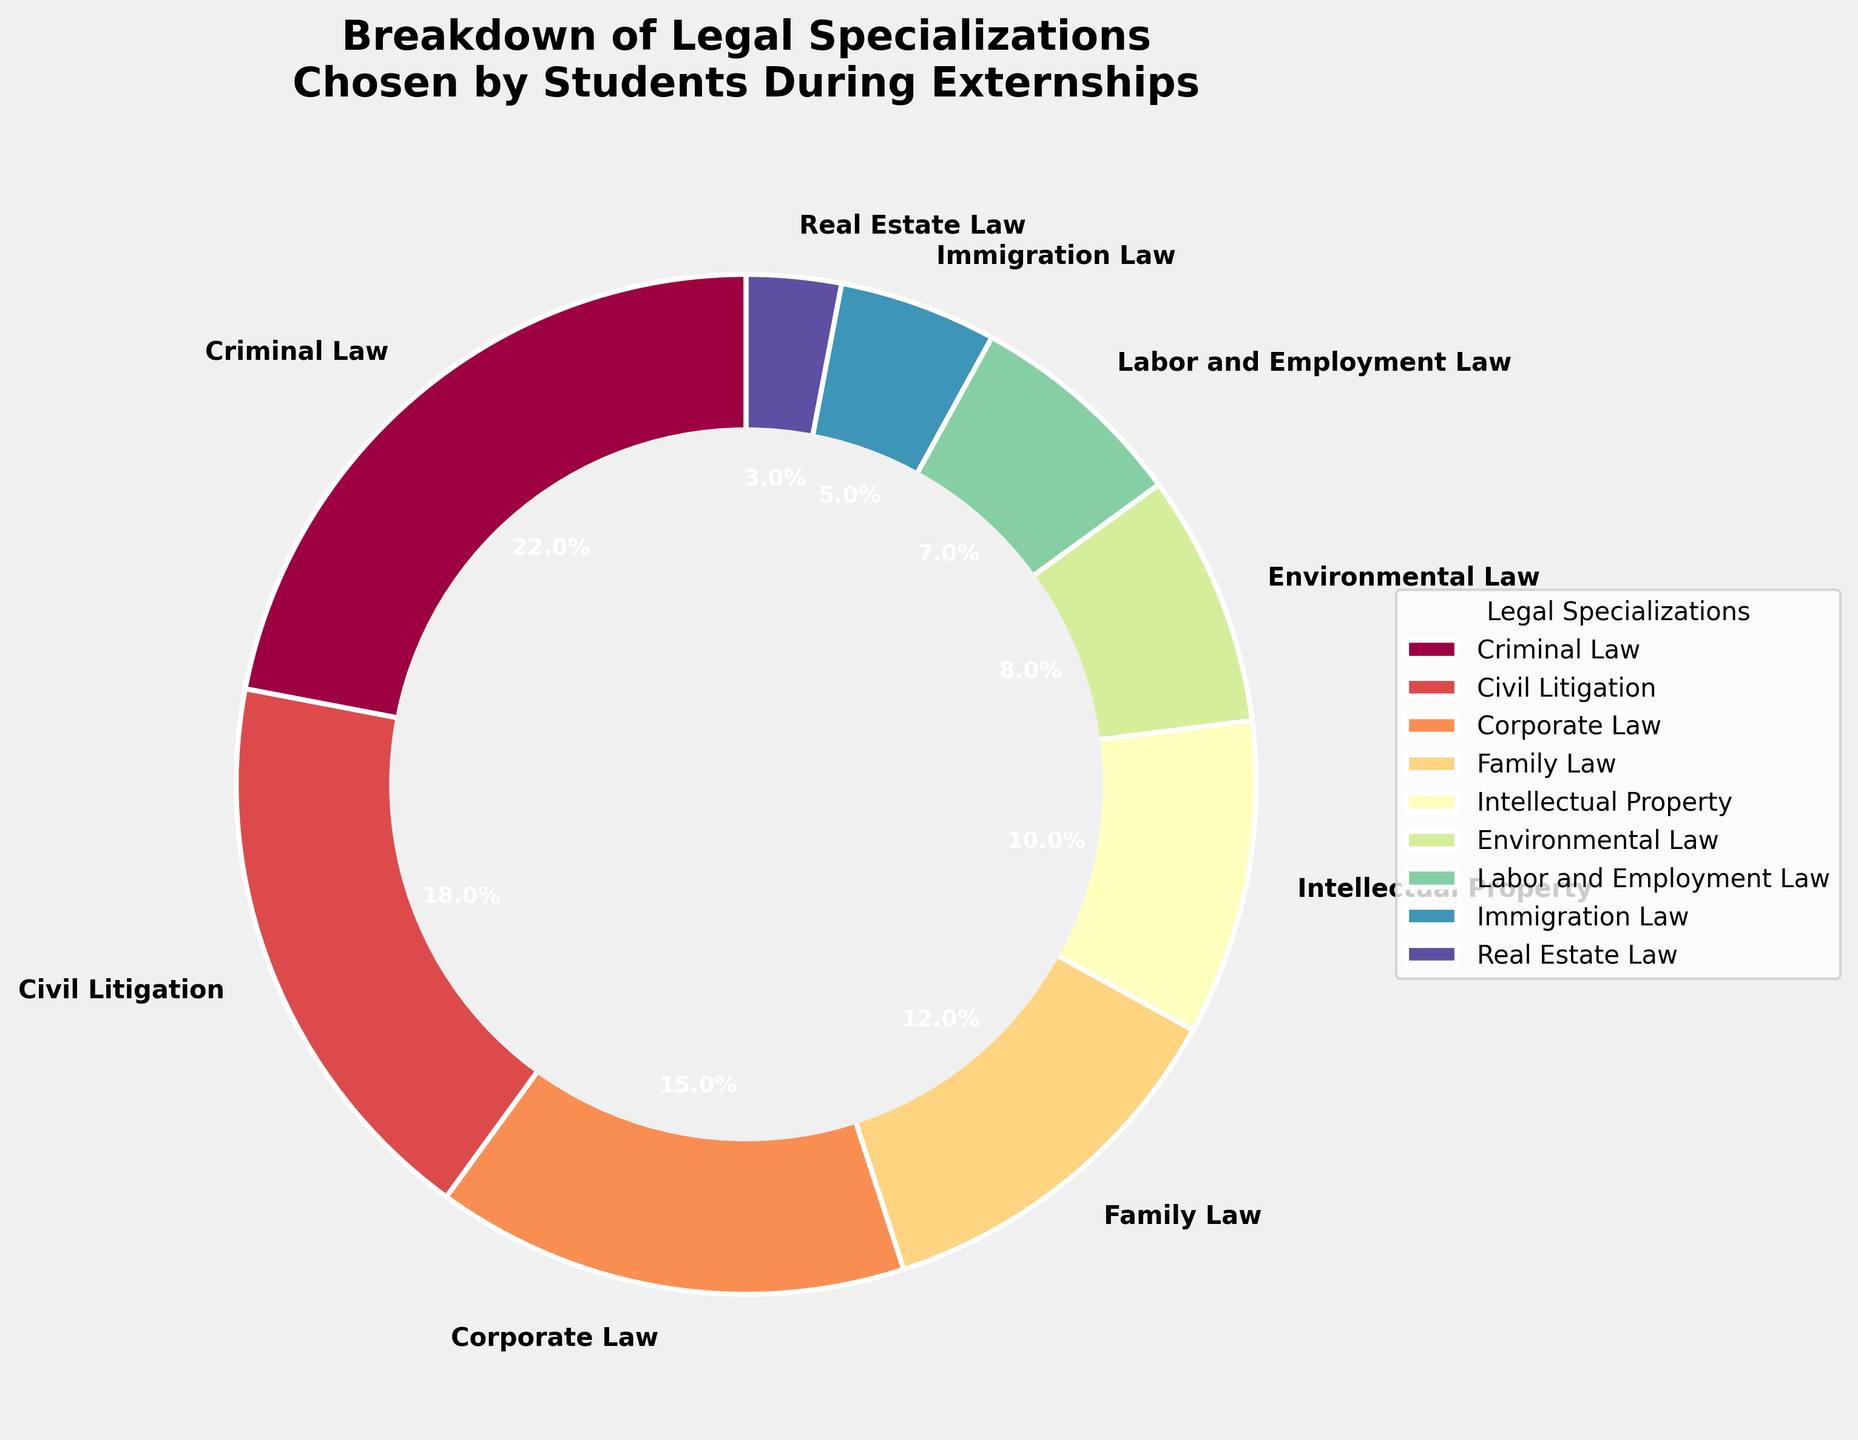Which legal specialization has the highest percentage of student participants? The figure shows different legal specializations with corresponding percentages, the segment with the highest percentage represents Criminal Law.
Answer: Criminal Law Which legal specialization has the lowest percentage of student participants? The figure lists all legal specializations and their percentages; the smallest segment represents Real Estate Law.
Answer: Real Estate Law Are there more students in Criminal Law externships compared to Civil Litigation and Corporate Law combined? Criminal Law has 22%, Civil Litigation has 18%, and Corporate Law has 15%. Adding Civil Litigation and Corporate Law gives 33%, which is greater than Criminal Law's 22%.
Answer: No What is the difference in percentage between Environmental Law and Labor and Employment Law? Environmental Law has 8% while Labor and Employment Law has 7%. The difference is 8% - 7% = 1%.
Answer: 1% How many legal specializations have a percentage of 10% or more? The figure shows percentages for each specialization. Criminal Law (22%), Civil Litigation (18%), Corporate Law (15%), Family Law (12%), and Intellectual Property (10%) all have 10% or more. There are 5 specializations in total.
Answer: 5 Which legal specialization has a 12% student participation rate? The figure shows the percentages for all specializations, Family Law is the only one with 12%.
Answer: Family Law How does the percentage of students in Corporate Law compare to those in Immigration Law? Corporate Law has 15% while Immigration Law has 5%. Thus, Corporate Law has a higher percentage of students.
Answer: Corporate Law has more What is the combined percentage of students in Intellectual Property and Environmental Law? Intellectual Property has 10% and Environmental Law has 8%. Adding these gives 10% + 8% = 18%.
Answer: 18% Which legal specializations have percentages under 10%? The figure shows that Environmental Law (8%), Labor and Employment Law (7%), Immigration Law (5%), and Real Estate Law (3%) are all under 10%.
Answer: Environmental Law, Labor and Employment Law, Immigration Law, Real Estate Law What percentage of students chose Family Law or Labor and Employment Law, and which field is more popular among the two? Family Law accounts for 12%, and Labor and Employment Law accounts for 7%. Adding these gives 12% + 7% = 19%. Family Law is more popular with a higher percentage.
Answer: Family Law, 19% 